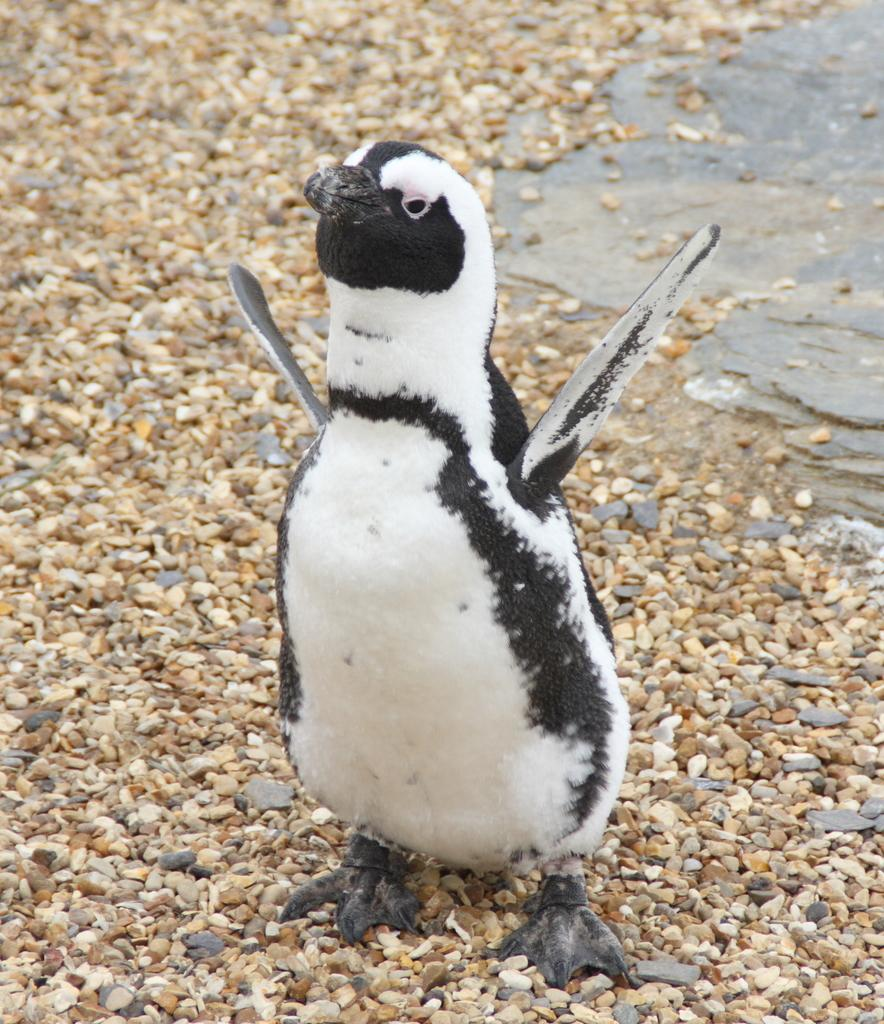What type of small stones are present in the image? There are pebbles in the image. What animal can be seen in the image? There is a penguin in the image. What color is the penguin in the image? The penguin is in black and white color. What type of roof can be seen in the image? There is no roof present in the image. What is the penguin's impulse in the image? The image does not depict the penguin's impulse; it simply shows the penguin in its natural color. 